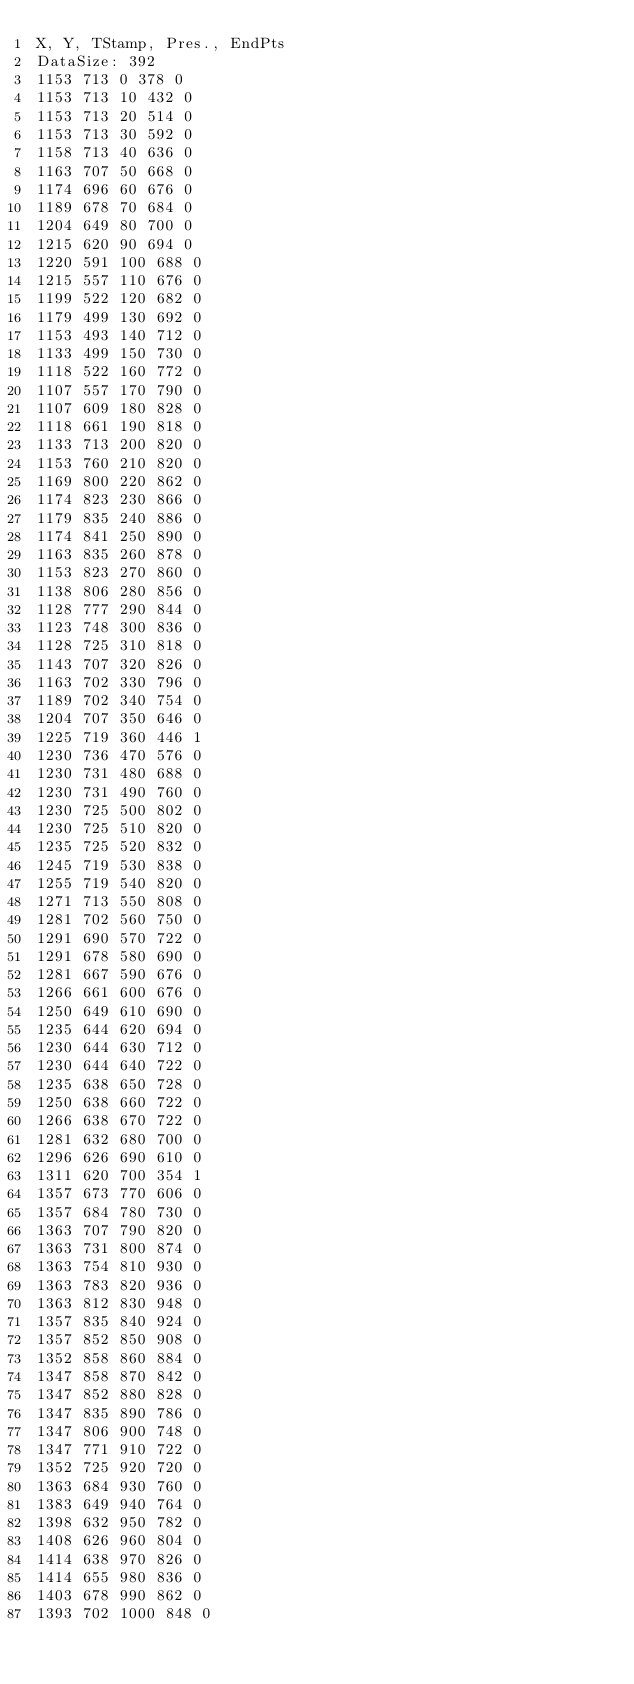Convert code to text. <code><loc_0><loc_0><loc_500><loc_500><_SML_>X, Y, TStamp, Pres., EndPts
DataSize: 392
1153 713 0 378 0
1153 713 10 432 0
1153 713 20 514 0
1153 713 30 592 0
1158 713 40 636 0
1163 707 50 668 0
1174 696 60 676 0
1189 678 70 684 0
1204 649 80 700 0
1215 620 90 694 0
1220 591 100 688 0
1215 557 110 676 0
1199 522 120 682 0
1179 499 130 692 0
1153 493 140 712 0
1133 499 150 730 0
1118 522 160 772 0
1107 557 170 790 0
1107 609 180 828 0
1118 661 190 818 0
1133 713 200 820 0
1153 760 210 820 0
1169 800 220 862 0
1174 823 230 866 0
1179 835 240 886 0
1174 841 250 890 0
1163 835 260 878 0
1153 823 270 860 0
1138 806 280 856 0
1128 777 290 844 0
1123 748 300 836 0
1128 725 310 818 0
1143 707 320 826 0
1163 702 330 796 0
1189 702 340 754 0
1204 707 350 646 0
1225 719 360 446 1
1230 736 470 576 0
1230 731 480 688 0
1230 731 490 760 0
1230 725 500 802 0
1230 725 510 820 0
1235 725 520 832 0
1245 719 530 838 0
1255 719 540 820 0
1271 713 550 808 0
1281 702 560 750 0
1291 690 570 722 0
1291 678 580 690 0
1281 667 590 676 0
1266 661 600 676 0
1250 649 610 690 0
1235 644 620 694 0
1230 644 630 712 0
1230 644 640 722 0
1235 638 650 728 0
1250 638 660 722 0
1266 638 670 722 0
1281 632 680 700 0
1296 626 690 610 0
1311 620 700 354 1
1357 673 770 606 0
1357 684 780 730 0
1363 707 790 820 0
1363 731 800 874 0
1363 754 810 930 0
1363 783 820 936 0
1363 812 830 948 0
1357 835 840 924 0
1357 852 850 908 0
1352 858 860 884 0
1347 858 870 842 0
1347 852 880 828 0
1347 835 890 786 0
1347 806 900 748 0
1347 771 910 722 0
1352 725 920 720 0
1363 684 930 760 0
1383 649 940 764 0
1398 632 950 782 0
1408 626 960 804 0
1414 638 970 826 0
1414 655 980 836 0
1403 678 990 862 0
1393 702 1000 848 0</code> 